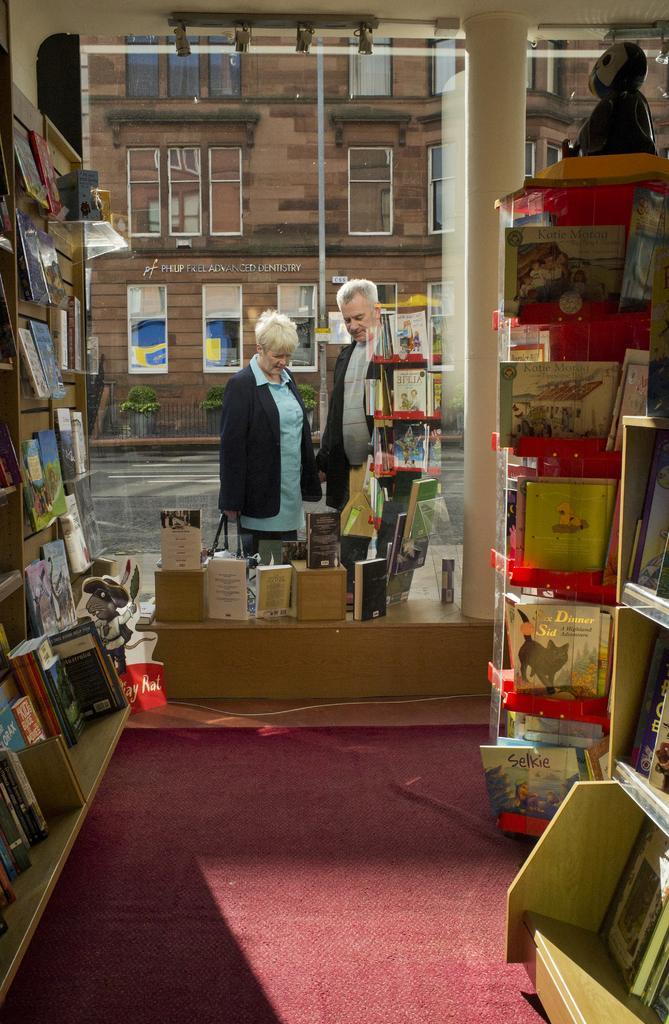In one or two sentences, can you explain what this image depicts? In this image we can see some books on the racks, some books on the tables, and stand, there are two persons, there is a building, windows, plants, there is a pole, there is a toy on the table. 